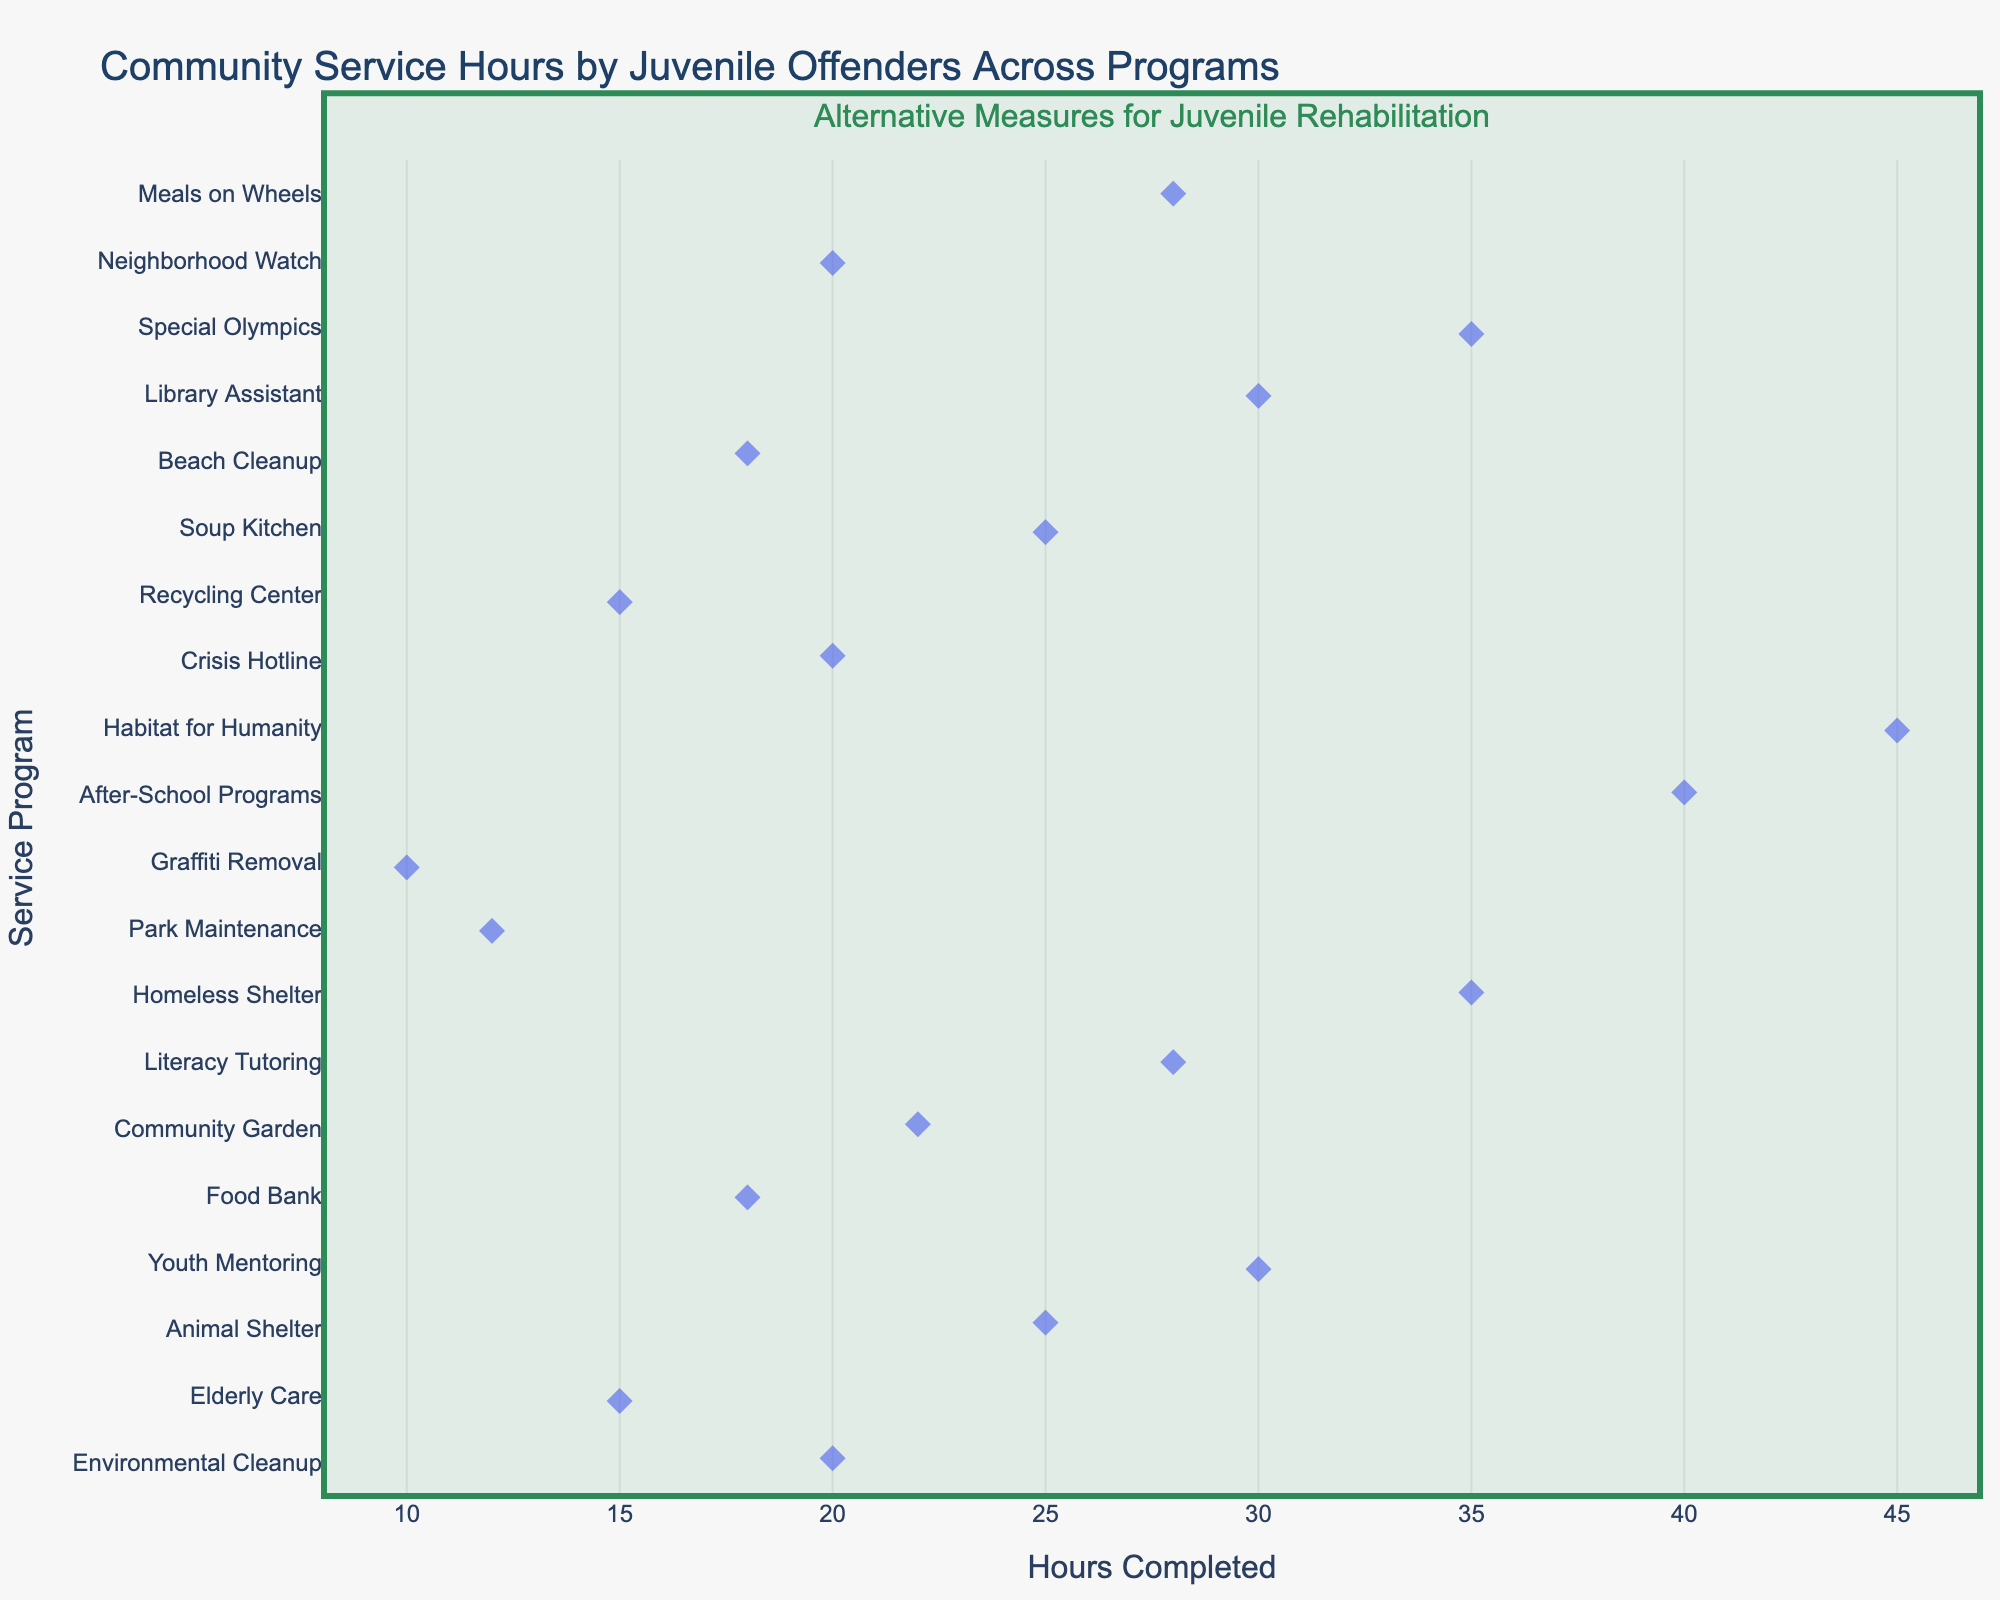What is the total number of service programs shown on the plot? Count the number of unique service programs listed along the y-axis.
Answer: 20 Which service program has the highest number of community service hours completed? Identify the program associated with the rightmost point on the x-axis.
Answer: Habitat for Humanity What is the range of community service hours across all programs? Subtract the smallest value on the x-axis from the largest value. (45 - 10)
Answer: 35 How many service programs have participants who completed exactly 20 hours? Count the number of points at the x-value of 20.
Answer: 3 In which service program were participants likely to complete the least hours? Identify the program associated with the leftmost point on the x-axis.
Answer: Graffiti Removal What is the median number of hours completed by juveniles in all programs? Organize all the hours and find the middle value, or the average of the two middle values if the count is even. (quickly visible in sorted viewing by the plot structure)
Answer: 22 Which service program has more hours completed, Meals on Wheels or Food Bank? Compare the x-axis positions of Meals on Wheels and Food Bank.
Answer: Meals on Wheels Are there more programs where participants completed 30 hours or 35 hours of service? Compare the number of points at x = 30 and x = 35.
Answer: Equal What is the average number of hours completed in programs listed? Sum all the hours completed across the programs and divide by the total number of programs. ((20 + 15 + 25 + 30 + 18 + 22 + 28 + 35 + 12 + 10 + 40 + 45 + 20 + 15 + 25 + 18 + 30 + 35 + 20 + 28) / 20) = 24.25
Answer: 24.25 Which three service programs have juveniles completed the most hours in? Identify the top three rightmost points and the associated programs.
Answer: Habitat for Humanity, After-School Programs, and Homeless Shelter 